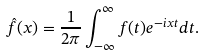Convert formula to latex. <formula><loc_0><loc_0><loc_500><loc_500>\hat { f } ( x ) = \frac { 1 } { 2 \pi } \int _ { - \infty } ^ { \infty } f ( t ) e ^ { - i x t } d t .</formula> 